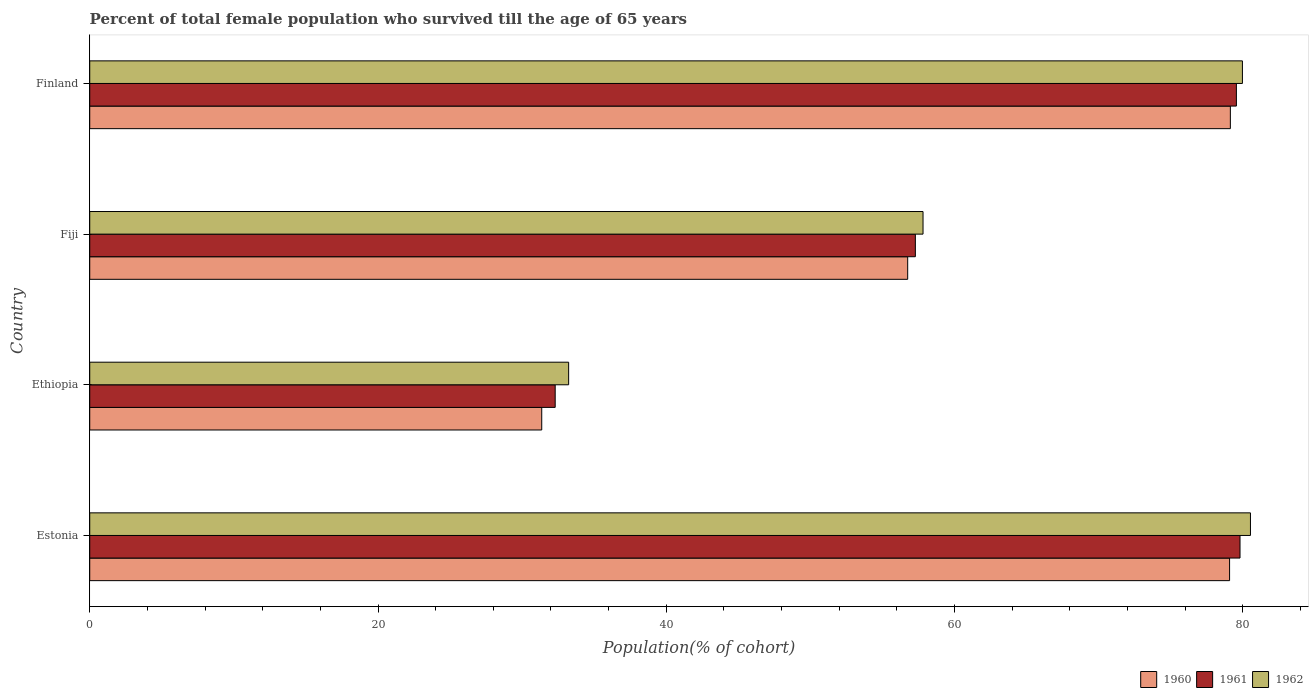Are the number of bars per tick equal to the number of legend labels?
Offer a terse response. Yes. What is the label of the 1st group of bars from the top?
Your answer should be compact. Finland. In how many cases, is the number of bars for a given country not equal to the number of legend labels?
Your answer should be compact. 0. What is the percentage of total female population who survived till the age of 65 years in 1962 in Fiji?
Your response must be concise. 57.81. Across all countries, what is the maximum percentage of total female population who survived till the age of 65 years in 1961?
Your answer should be compact. 79.81. Across all countries, what is the minimum percentage of total female population who survived till the age of 65 years in 1960?
Make the answer very short. 31.36. In which country was the percentage of total female population who survived till the age of 65 years in 1960 minimum?
Give a very brief answer. Ethiopia. What is the total percentage of total female population who survived till the age of 65 years in 1960 in the graph?
Provide a succinct answer. 246.33. What is the difference between the percentage of total female population who survived till the age of 65 years in 1962 in Ethiopia and that in Finland?
Give a very brief answer. -46.75. What is the difference between the percentage of total female population who survived till the age of 65 years in 1960 in Estonia and the percentage of total female population who survived till the age of 65 years in 1961 in Ethiopia?
Keep it short and to the point. 46.79. What is the average percentage of total female population who survived till the age of 65 years in 1962 per country?
Your response must be concise. 62.89. What is the difference between the percentage of total female population who survived till the age of 65 years in 1961 and percentage of total female population who survived till the age of 65 years in 1960 in Estonia?
Offer a terse response. 0.72. In how many countries, is the percentage of total female population who survived till the age of 65 years in 1961 greater than 68 %?
Your response must be concise. 2. What is the ratio of the percentage of total female population who survived till the age of 65 years in 1960 in Estonia to that in Finland?
Ensure brevity in your answer.  1. Is the percentage of total female population who survived till the age of 65 years in 1961 in Estonia less than that in Finland?
Offer a very short reply. No. What is the difference between the highest and the second highest percentage of total female population who survived till the age of 65 years in 1961?
Ensure brevity in your answer.  0.25. What is the difference between the highest and the lowest percentage of total female population who survived till the age of 65 years in 1962?
Your answer should be compact. 47.3. In how many countries, is the percentage of total female population who survived till the age of 65 years in 1962 greater than the average percentage of total female population who survived till the age of 65 years in 1962 taken over all countries?
Provide a short and direct response. 2. What does the 1st bar from the top in Fiji represents?
Provide a succinct answer. 1962. What does the 1st bar from the bottom in Finland represents?
Ensure brevity in your answer.  1960. Are all the bars in the graph horizontal?
Ensure brevity in your answer.  Yes. How many countries are there in the graph?
Make the answer very short. 4. Are the values on the major ticks of X-axis written in scientific E-notation?
Offer a very short reply. No. Where does the legend appear in the graph?
Your response must be concise. Bottom right. How many legend labels are there?
Provide a short and direct response. 3. How are the legend labels stacked?
Ensure brevity in your answer.  Horizontal. What is the title of the graph?
Offer a terse response. Percent of total female population who survived till the age of 65 years. Does "1983" appear as one of the legend labels in the graph?
Ensure brevity in your answer.  No. What is the label or title of the X-axis?
Give a very brief answer. Population(% of cohort). What is the Population(% of cohort) in 1960 in Estonia?
Offer a very short reply. 79.08. What is the Population(% of cohort) in 1961 in Estonia?
Your response must be concise. 79.81. What is the Population(% of cohort) in 1962 in Estonia?
Provide a succinct answer. 80.53. What is the Population(% of cohort) of 1960 in Ethiopia?
Offer a terse response. 31.36. What is the Population(% of cohort) in 1961 in Ethiopia?
Ensure brevity in your answer.  32.29. What is the Population(% of cohort) in 1962 in Ethiopia?
Keep it short and to the point. 33.23. What is the Population(% of cohort) of 1960 in Fiji?
Offer a very short reply. 56.75. What is the Population(% of cohort) in 1961 in Fiji?
Ensure brevity in your answer.  57.28. What is the Population(% of cohort) in 1962 in Fiji?
Provide a succinct answer. 57.81. What is the Population(% of cohort) in 1960 in Finland?
Your answer should be very brief. 79.14. What is the Population(% of cohort) in 1961 in Finland?
Keep it short and to the point. 79.56. What is the Population(% of cohort) in 1962 in Finland?
Your response must be concise. 79.97. Across all countries, what is the maximum Population(% of cohort) in 1960?
Provide a short and direct response. 79.14. Across all countries, what is the maximum Population(% of cohort) of 1961?
Make the answer very short. 79.81. Across all countries, what is the maximum Population(% of cohort) in 1962?
Ensure brevity in your answer.  80.53. Across all countries, what is the minimum Population(% of cohort) in 1960?
Give a very brief answer. 31.36. Across all countries, what is the minimum Population(% of cohort) in 1961?
Ensure brevity in your answer.  32.29. Across all countries, what is the minimum Population(% of cohort) in 1962?
Offer a terse response. 33.23. What is the total Population(% of cohort) in 1960 in the graph?
Your response must be concise. 246.33. What is the total Population(% of cohort) of 1961 in the graph?
Keep it short and to the point. 248.94. What is the total Population(% of cohort) in 1962 in the graph?
Ensure brevity in your answer.  251.55. What is the difference between the Population(% of cohort) of 1960 in Estonia and that in Ethiopia?
Your answer should be compact. 47.72. What is the difference between the Population(% of cohort) of 1961 in Estonia and that in Ethiopia?
Offer a terse response. 47.51. What is the difference between the Population(% of cohort) of 1962 in Estonia and that in Ethiopia?
Your answer should be compact. 47.3. What is the difference between the Population(% of cohort) in 1960 in Estonia and that in Fiji?
Offer a very short reply. 22.33. What is the difference between the Population(% of cohort) of 1961 in Estonia and that in Fiji?
Your response must be concise. 22.52. What is the difference between the Population(% of cohort) in 1962 in Estonia and that in Fiji?
Offer a terse response. 22.72. What is the difference between the Population(% of cohort) of 1960 in Estonia and that in Finland?
Provide a short and direct response. -0.06. What is the difference between the Population(% of cohort) in 1961 in Estonia and that in Finland?
Give a very brief answer. 0.25. What is the difference between the Population(% of cohort) of 1962 in Estonia and that in Finland?
Offer a terse response. 0.56. What is the difference between the Population(% of cohort) in 1960 in Ethiopia and that in Fiji?
Make the answer very short. -25.39. What is the difference between the Population(% of cohort) of 1961 in Ethiopia and that in Fiji?
Provide a succinct answer. -24.99. What is the difference between the Population(% of cohort) in 1962 in Ethiopia and that in Fiji?
Provide a short and direct response. -24.59. What is the difference between the Population(% of cohort) in 1960 in Ethiopia and that in Finland?
Provide a short and direct response. -47.78. What is the difference between the Population(% of cohort) of 1961 in Ethiopia and that in Finland?
Your response must be concise. -47.26. What is the difference between the Population(% of cohort) in 1962 in Ethiopia and that in Finland?
Keep it short and to the point. -46.75. What is the difference between the Population(% of cohort) of 1960 in Fiji and that in Finland?
Offer a very short reply. -22.39. What is the difference between the Population(% of cohort) in 1961 in Fiji and that in Finland?
Keep it short and to the point. -22.27. What is the difference between the Population(% of cohort) in 1962 in Fiji and that in Finland?
Offer a terse response. -22.16. What is the difference between the Population(% of cohort) in 1960 in Estonia and the Population(% of cohort) in 1961 in Ethiopia?
Your response must be concise. 46.79. What is the difference between the Population(% of cohort) of 1960 in Estonia and the Population(% of cohort) of 1962 in Ethiopia?
Provide a succinct answer. 45.86. What is the difference between the Population(% of cohort) in 1961 in Estonia and the Population(% of cohort) in 1962 in Ethiopia?
Your answer should be very brief. 46.58. What is the difference between the Population(% of cohort) in 1960 in Estonia and the Population(% of cohort) in 1961 in Fiji?
Keep it short and to the point. 21.8. What is the difference between the Population(% of cohort) of 1960 in Estonia and the Population(% of cohort) of 1962 in Fiji?
Offer a very short reply. 21.27. What is the difference between the Population(% of cohort) of 1961 in Estonia and the Population(% of cohort) of 1962 in Fiji?
Your answer should be very brief. 21.99. What is the difference between the Population(% of cohort) in 1960 in Estonia and the Population(% of cohort) in 1961 in Finland?
Provide a succinct answer. -0.47. What is the difference between the Population(% of cohort) in 1960 in Estonia and the Population(% of cohort) in 1962 in Finland?
Give a very brief answer. -0.89. What is the difference between the Population(% of cohort) in 1961 in Estonia and the Population(% of cohort) in 1962 in Finland?
Make the answer very short. -0.17. What is the difference between the Population(% of cohort) in 1960 in Ethiopia and the Population(% of cohort) in 1961 in Fiji?
Keep it short and to the point. -25.92. What is the difference between the Population(% of cohort) of 1960 in Ethiopia and the Population(% of cohort) of 1962 in Fiji?
Give a very brief answer. -26.45. What is the difference between the Population(% of cohort) in 1961 in Ethiopia and the Population(% of cohort) in 1962 in Fiji?
Your answer should be compact. -25.52. What is the difference between the Population(% of cohort) in 1960 in Ethiopia and the Population(% of cohort) in 1961 in Finland?
Keep it short and to the point. -48.2. What is the difference between the Population(% of cohort) in 1960 in Ethiopia and the Population(% of cohort) in 1962 in Finland?
Your answer should be very brief. -48.61. What is the difference between the Population(% of cohort) in 1961 in Ethiopia and the Population(% of cohort) in 1962 in Finland?
Your answer should be compact. -47.68. What is the difference between the Population(% of cohort) in 1960 in Fiji and the Population(% of cohort) in 1961 in Finland?
Keep it short and to the point. -22.81. What is the difference between the Population(% of cohort) in 1960 in Fiji and the Population(% of cohort) in 1962 in Finland?
Ensure brevity in your answer.  -23.22. What is the difference between the Population(% of cohort) of 1961 in Fiji and the Population(% of cohort) of 1962 in Finland?
Give a very brief answer. -22.69. What is the average Population(% of cohort) of 1960 per country?
Your response must be concise. 61.58. What is the average Population(% of cohort) of 1961 per country?
Your answer should be compact. 62.23. What is the average Population(% of cohort) of 1962 per country?
Ensure brevity in your answer.  62.89. What is the difference between the Population(% of cohort) in 1960 and Population(% of cohort) in 1961 in Estonia?
Offer a terse response. -0.72. What is the difference between the Population(% of cohort) in 1960 and Population(% of cohort) in 1962 in Estonia?
Keep it short and to the point. -1.45. What is the difference between the Population(% of cohort) in 1961 and Population(% of cohort) in 1962 in Estonia?
Offer a very short reply. -0.72. What is the difference between the Population(% of cohort) of 1960 and Population(% of cohort) of 1961 in Ethiopia?
Keep it short and to the point. -0.93. What is the difference between the Population(% of cohort) of 1960 and Population(% of cohort) of 1962 in Ethiopia?
Provide a succinct answer. -1.87. What is the difference between the Population(% of cohort) in 1961 and Population(% of cohort) in 1962 in Ethiopia?
Keep it short and to the point. -0.93. What is the difference between the Population(% of cohort) of 1960 and Population(% of cohort) of 1961 in Fiji?
Your answer should be compact. -0.53. What is the difference between the Population(% of cohort) of 1960 and Population(% of cohort) of 1962 in Fiji?
Give a very brief answer. -1.06. What is the difference between the Population(% of cohort) of 1961 and Population(% of cohort) of 1962 in Fiji?
Give a very brief answer. -0.53. What is the difference between the Population(% of cohort) of 1960 and Population(% of cohort) of 1961 in Finland?
Provide a short and direct response. -0.42. What is the difference between the Population(% of cohort) of 1960 and Population(% of cohort) of 1962 in Finland?
Your response must be concise. -0.84. What is the difference between the Population(% of cohort) in 1961 and Population(% of cohort) in 1962 in Finland?
Your answer should be very brief. -0.42. What is the ratio of the Population(% of cohort) of 1960 in Estonia to that in Ethiopia?
Provide a succinct answer. 2.52. What is the ratio of the Population(% of cohort) of 1961 in Estonia to that in Ethiopia?
Ensure brevity in your answer.  2.47. What is the ratio of the Population(% of cohort) of 1962 in Estonia to that in Ethiopia?
Ensure brevity in your answer.  2.42. What is the ratio of the Population(% of cohort) in 1960 in Estonia to that in Fiji?
Make the answer very short. 1.39. What is the ratio of the Population(% of cohort) of 1961 in Estonia to that in Fiji?
Make the answer very short. 1.39. What is the ratio of the Population(% of cohort) in 1962 in Estonia to that in Fiji?
Ensure brevity in your answer.  1.39. What is the ratio of the Population(% of cohort) of 1961 in Estonia to that in Finland?
Your answer should be very brief. 1. What is the ratio of the Population(% of cohort) in 1960 in Ethiopia to that in Fiji?
Offer a terse response. 0.55. What is the ratio of the Population(% of cohort) in 1961 in Ethiopia to that in Fiji?
Keep it short and to the point. 0.56. What is the ratio of the Population(% of cohort) in 1962 in Ethiopia to that in Fiji?
Your answer should be compact. 0.57. What is the ratio of the Population(% of cohort) of 1960 in Ethiopia to that in Finland?
Keep it short and to the point. 0.4. What is the ratio of the Population(% of cohort) of 1961 in Ethiopia to that in Finland?
Offer a terse response. 0.41. What is the ratio of the Population(% of cohort) of 1962 in Ethiopia to that in Finland?
Your answer should be very brief. 0.42. What is the ratio of the Population(% of cohort) of 1960 in Fiji to that in Finland?
Give a very brief answer. 0.72. What is the ratio of the Population(% of cohort) of 1961 in Fiji to that in Finland?
Offer a very short reply. 0.72. What is the ratio of the Population(% of cohort) in 1962 in Fiji to that in Finland?
Give a very brief answer. 0.72. What is the difference between the highest and the second highest Population(% of cohort) in 1960?
Provide a succinct answer. 0.06. What is the difference between the highest and the second highest Population(% of cohort) of 1961?
Your response must be concise. 0.25. What is the difference between the highest and the second highest Population(% of cohort) of 1962?
Provide a succinct answer. 0.56. What is the difference between the highest and the lowest Population(% of cohort) of 1960?
Keep it short and to the point. 47.78. What is the difference between the highest and the lowest Population(% of cohort) in 1961?
Ensure brevity in your answer.  47.51. What is the difference between the highest and the lowest Population(% of cohort) in 1962?
Your answer should be very brief. 47.3. 